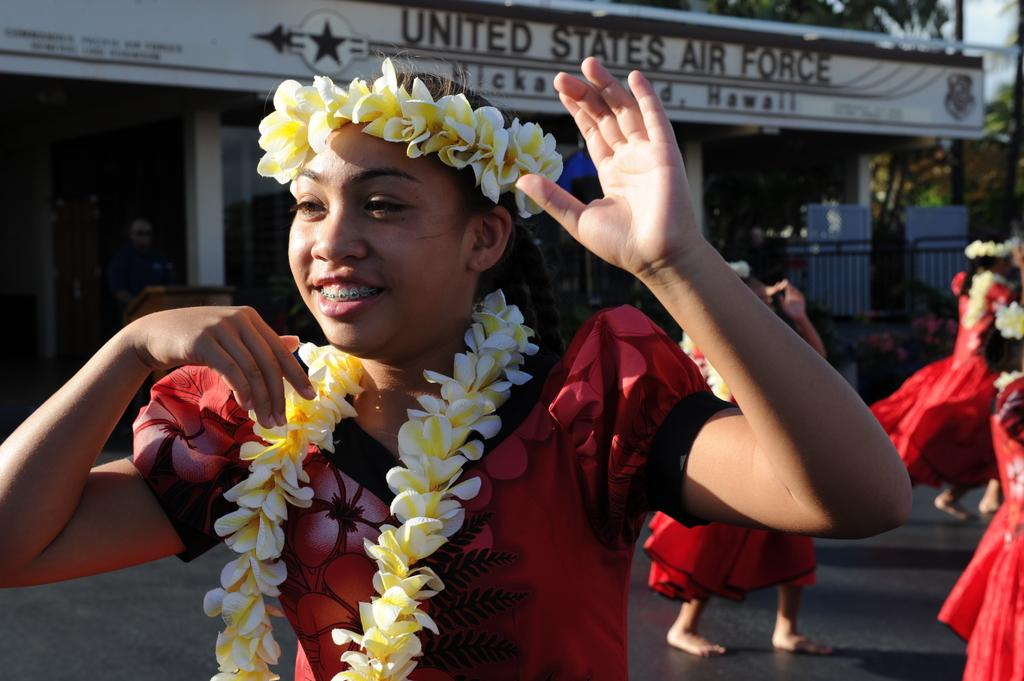What are the people in the image wearing? The people in the image are wearing garlands. What can be seen in the foreground of the image? There is a road visible in the image. What is located in the background of the image? There is a building, leaves, a podium, and a person in the background of the image. What is visible in the sky in the image? The sky is visible in the background of the image. What else can be seen in the background of the image? There are objects in the background of the image. What type of blade can be seen cutting the harmony in the image? There is no blade or harmony present in the image. How many oranges are visible on the podium in the image? There are no oranges visible in the image; the podium is empty. 